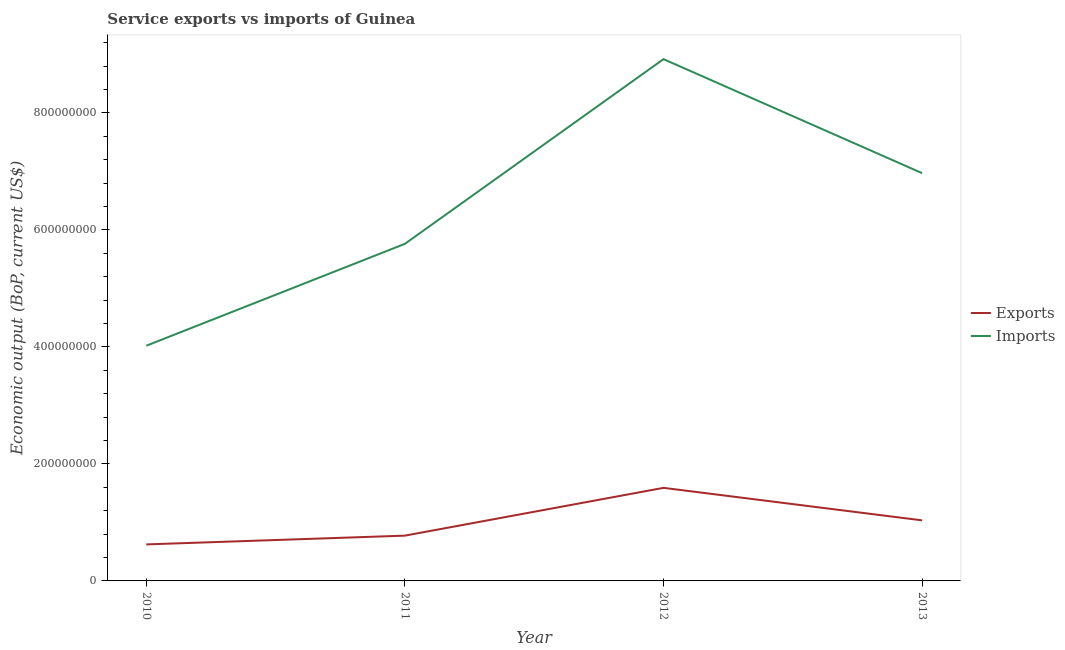How many different coloured lines are there?
Provide a succinct answer. 2. Is the number of lines equal to the number of legend labels?
Provide a short and direct response. Yes. What is the amount of service exports in 2011?
Offer a very short reply. 7.74e+07. Across all years, what is the maximum amount of service imports?
Make the answer very short. 8.92e+08. Across all years, what is the minimum amount of service imports?
Give a very brief answer. 4.02e+08. In which year was the amount of service exports maximum?
Your answer should be compact. 2012. In which year was the amount of service exports minimum?
Ensure brevity in your answer.  2010. What is the total amount of service imports in the graph?
Your answer should be compact. 2.57e+09. What is the difference between the amount of service exports in 2010 and that in 2011?
Offer a terse response. -1.50e+07. What is the difference between the amount of service exports in 2012 and the amount of service imports in 2013?
Offer a very short reply. -5.38e+08. What is the average amount of service exports per year?
Give a very brief answer. 1.01e+08. In the year 2010, what is the difference between the amount of service imports and amount of service exports?
Your response must be concise. 3.40e+08. What is the ratio of the amount of service imports in 2011 to that in 2013?
Provide a succinct answer. 0.83. Is the amount of service exports in 2012 less than that in 2013?
Offer a terse response. No. Is the difference between the amount of service imports in 2010 and 2012 greater than the difference between the amount of service exports in 2010 and 2012?
Offer a very short reply. No. What is the difference between the highest and the second highest amount of service exports?
Keep it short and to the point. 5.55e+07. What is the difference between the highest and the lowest amount of service exports?
Ensure brevity in your answer.  9.66e+07. In how many years, is the amount of service imports greater than the average amount of service imports taken over all years?
Your response must be concise. 2. Is the sum of the amount of service imports in 2011 and 2012 greater than the maximum amount of service exports across all years?
Your response must be concise. Yes. Is the amount of service exports strictly greater than the amount of service imports over the years?
Your answer should be compact. No. Is the amount of service exports strictly less than the amount of service imports over the years?
Keep it short and to the point. Yes. How many lines are there?
Your response must be concise. 2. How many years are there in the graph?
Your answer should be compact. 4. Where does the legend appear in the graph?
Your answer should be compact. Center right. What is the title of the graph?
Give a very brief answer. Service exports vs imports of Guinea. What is the label or title of the Y-axis?
Provide a short and direct response. Economic output (BoP, current US$). What is the Economic output (BoP, current US$) of Exports in 2010?
Make the answer very short. 6.24e+07. What is the Economic output (BoP, current US$) in Imports in 2010?
Keep it short and to the point. 4.02e+08. What is the Economic output (BoP, current US$) of Exports in 2011?
Offer a very short reply. 7.74e+07. What is the Economic output (BoP, current US$) of Imports in 2011?
Your answer should be compact. 5.76e+08. What is the Economic output (BoP, current US$) in Exports in 2012?
Offer a terse response. 1.59e+08. What is the Economic output (BoP, current US$) of Imports in 2012?
Your answer should be compact. 8.92e+08. What is the Economic output (BoP, current US$) of Exports in 2013?
Offer a terse response. 1.04e+08. What is the Economic output (BoP, current US$) in Imports in 2013?
Your answer should be very brief. 6.97e+08. Across all years, what is the maximum Economic output (BoP, current US$) in Exports?
Your answer should be compact. 1.59e+08. Across all years, what is the maximum Economic output (BoP, current US$) of Imports?
Provide a succinct answer. 8.92e+08. Across all years, what is the minimum Economic output (BoP, current US$) of Exports?
Keep it short and to the point. 6.24e+07. Across all years, what is the minimum Economic output (BoP, current US$) in Imports?
Keep it short and to the point. 4.02e+08. What is the total Economic output (BoP, current US$) in Exports in the graph?
Offer a very short reply. 4.02e+08. What is the total Economic output (BoP, current US$) in Imports in the graph?
Your answer should be very brief. 2.57e+09. What is the difference between the Economic output (BoP, current US$) in Exports in 2010 and that in 2011?
Your answer should be compact. -1.50e+07. What is the difference between the Economic output (BoP, current US$) of Imports in 2010 and that in 2011?
Your answer should be very brief. -1.74e+08. What is the difference between the Economic output (BoP, current US$) of Exports in 2010 and that in 2012?
Ensure brevity in your answer.  -9.66e+07. What is the difference between the Economic output (BoP, current US$) of Imports in 2010 and that in 2012?
Your answer should be compact. -4.90e+08. What is the difference between the Economic output (BoP, current US$) in Exports in 2010 and that in 2013?
Offer a very short reply. -4.11e+07. What is the difference between the Economic output (BoP, current US$) in Imports in 2010 and that in 2013?
Your response must be concise. -2.95e+08. What is the difference between the Economic output (BoP, current US$) of Exports in 2011 and that in 2012?
Your response must be concise. -8.17e+07. What is the difference between the Economic output (BoP, current US$) of Imports in 2011 and that in 2012?
Keep it short and to the point. -3.16e+08. What is the difference between the Economic output (BoP, current US$) of Exports in 2011 and that in 2013?
Your response must be concise. -2.62e+07. What is the difference between the Economic output (BoP, current US$) in Imports in 2011 and that in 2013?
Your answer should be compact. -1.21e+08. What is the difference between the Economic output (BoP, current US$) in Exports in 2012 and that in 2013?
Give a very brief answer. 5.55e+07. What is the difference between the Economic output (BoP, current US$) in Imports in 2012 and that in 2013?
Make the answer very short. 1.95e+08. What is the difference between the Economic output (BoP, current US$) in Exports in 2010 and the Economic output (BoP, current US$) in Imports in 2011?
Your response must be concise. -5.14e+08. What is the difference between the Economic output (BoP, current US$) of Exports in 2010 and the Economic output (BoP, current US$) of Imports in 2012?
Offer a terse response. -8.29e+08. What is the difference between the Economic output (BoP, current US$) in Exports in 2010 and the Economic output (BoP, current US$) in Imports in 2013?
Offer a very short reply. -6.34e+08. What is the difference between the Economic output (BoP, current US$) of Exports in 2011 and the Economic output (BoP, current US$) of Imports in 2012?
Your answer should be compact. -8.14e+08. What is the difference between the Economic output (BoP, current US$) in Exports in 2011 and the Economic output (BoP, current US$) in Imports in 2013?
Your answer should be compact. -6.20e+08. What is the difference between the Economic output (BoP, current US$) in Exports in 2012 and the Economic output (BoP, current US$) in Imports in 2013?
Offer a terse response. -5.38e+08. What is the average Economic output (BoP, current US$) of Exports per year?
Keep it short and to the point. 1.01e+08. What is the average Economic output (BoP, current US$) of Imports per year?
Offer a very short reply. 6.42e+08. In the year 2010, what is the difference between the Economic output (BoP, current US$) in Exports and Economic output (BoP, current US$) in Imports?
Your response must be concise. -3.40e+08. In the year 2011, what is the difference between the Economic output (BoP, current US$) of Exports and Economic output (BoP, current US$) of Imports?
Your answer should be compact. -4.99e+08. In the year 2012, what is the difference between the Economic output (BoP, current US$) in Exports and Economic output (BoP, current US$) in Imports?
Offer a very short reply. -7.33e+08. In the year 2013, what is the difference between the Economic output (BoP, current US$) of Exports and Economic output (BoP, current US$) of Imports?
Your response must be concise. -5.93e+08. What is the ratio of the Economic output (BoP, current US$) in Exports in 2010 to that in 2011?
Ensure brevity in your answer.  0.81. What is the ratio of the Economic output (BoP, current US$) in Imports in 2010 to that in 2011?
Keep it short and to the point. 0.7. What is the ratio of the Economic output (BoP, current US$) of Exports in 2010 to that in 2012?
Your answer should be very brief. 0.39. What is the ratio of the Economic output (BoP, current US$) in Imports in 2010 to that in 2012?
Your answer should be compact. 0.45. What is the ratio of the Economic output (BoP, current US$) of Exports in 2010 to that in 2013?
Provide a short and direct response. 0.6. What is the ratio of the Economic output (BoP, current US$) in Imports in 2010 to that in 2013?
Make the answer very short. 0.58. What is the ratio of the Economic output (BoP, current US$) of Exports in 2011 to that in 2012?
Your answer should be very brief. 0.49. What is the ratio of the Economic output (BoP, current US$) in Imports in 2011 to that in 2012?
Keep it short and to the point. 0.65. What is the ratio of the Economic output (BoP, current US$) of Exports in 2011 to that in 2013?
Provide a succinct answer. 0.75. What is the ratio of the Economic output (BoP, current US$) in Imports in 2011 to that in 2013?
Provide a short and direct response. 0.83. What is the ratio of the Economic output (BoP, current US$) of Exports in 2012 to that in 2013?
Offer a very short reply. 1.54. What is the ratio of the Economic output (BoP, current US$) in Imports in 2012 to that in 2013?
Make the answer very short. 1.28. What is the difference between the highest and the second highest Economic output (BoP, current US$) of Exports?
Your answer should be very brief. 5.55e+07. What is the difference between the highest and the second highest Economic output (BoP, current US$) of Imports?
Give a very brief answer. 1.95e+08. What is the difference between the highest and the lowest Economic output (BoP, current US$) of Exports?
Provide a short and direct response. 9.66e+07. What is the difference between the highest and the lowest Economic output (BoP, current US$) in Imports?
Provide a succinct answer. 4.90e+08. 